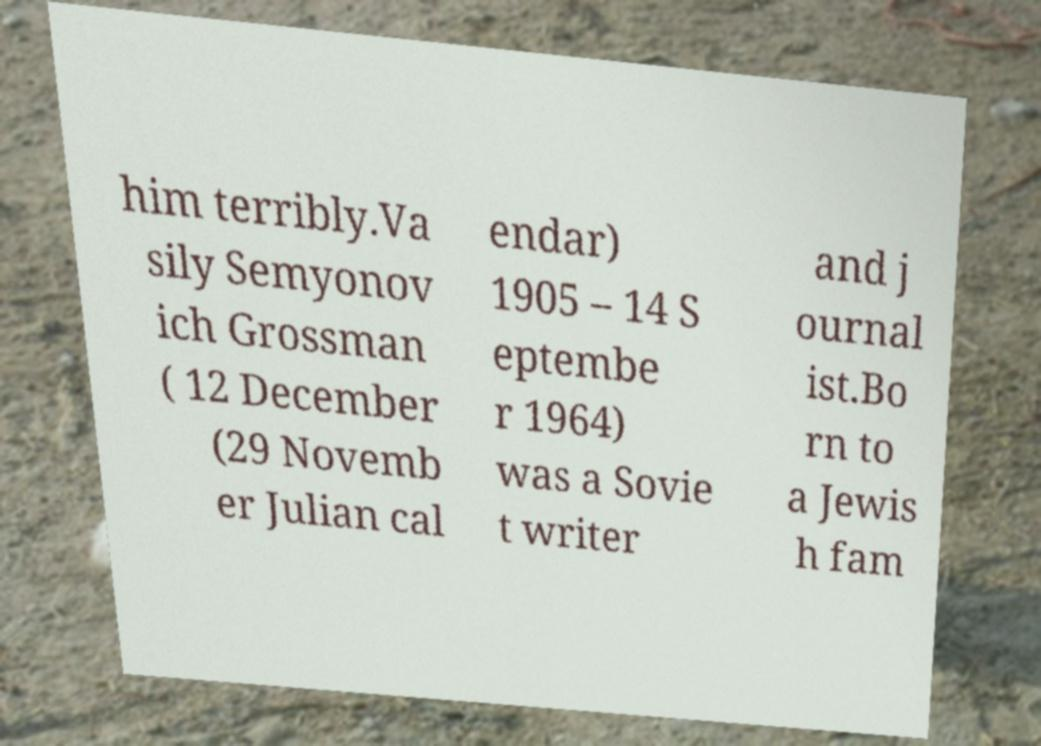Please read and relay the text visible in this image. What does it say? him terribly.Va sily Semyonov ich Grossman ( 12 December (29 Novemb er Julian cal endar) 1905 – 14 S eptembe r 1964) was a Sovie t writer and j ournal ist.Bo rn to a Jewis h fam 